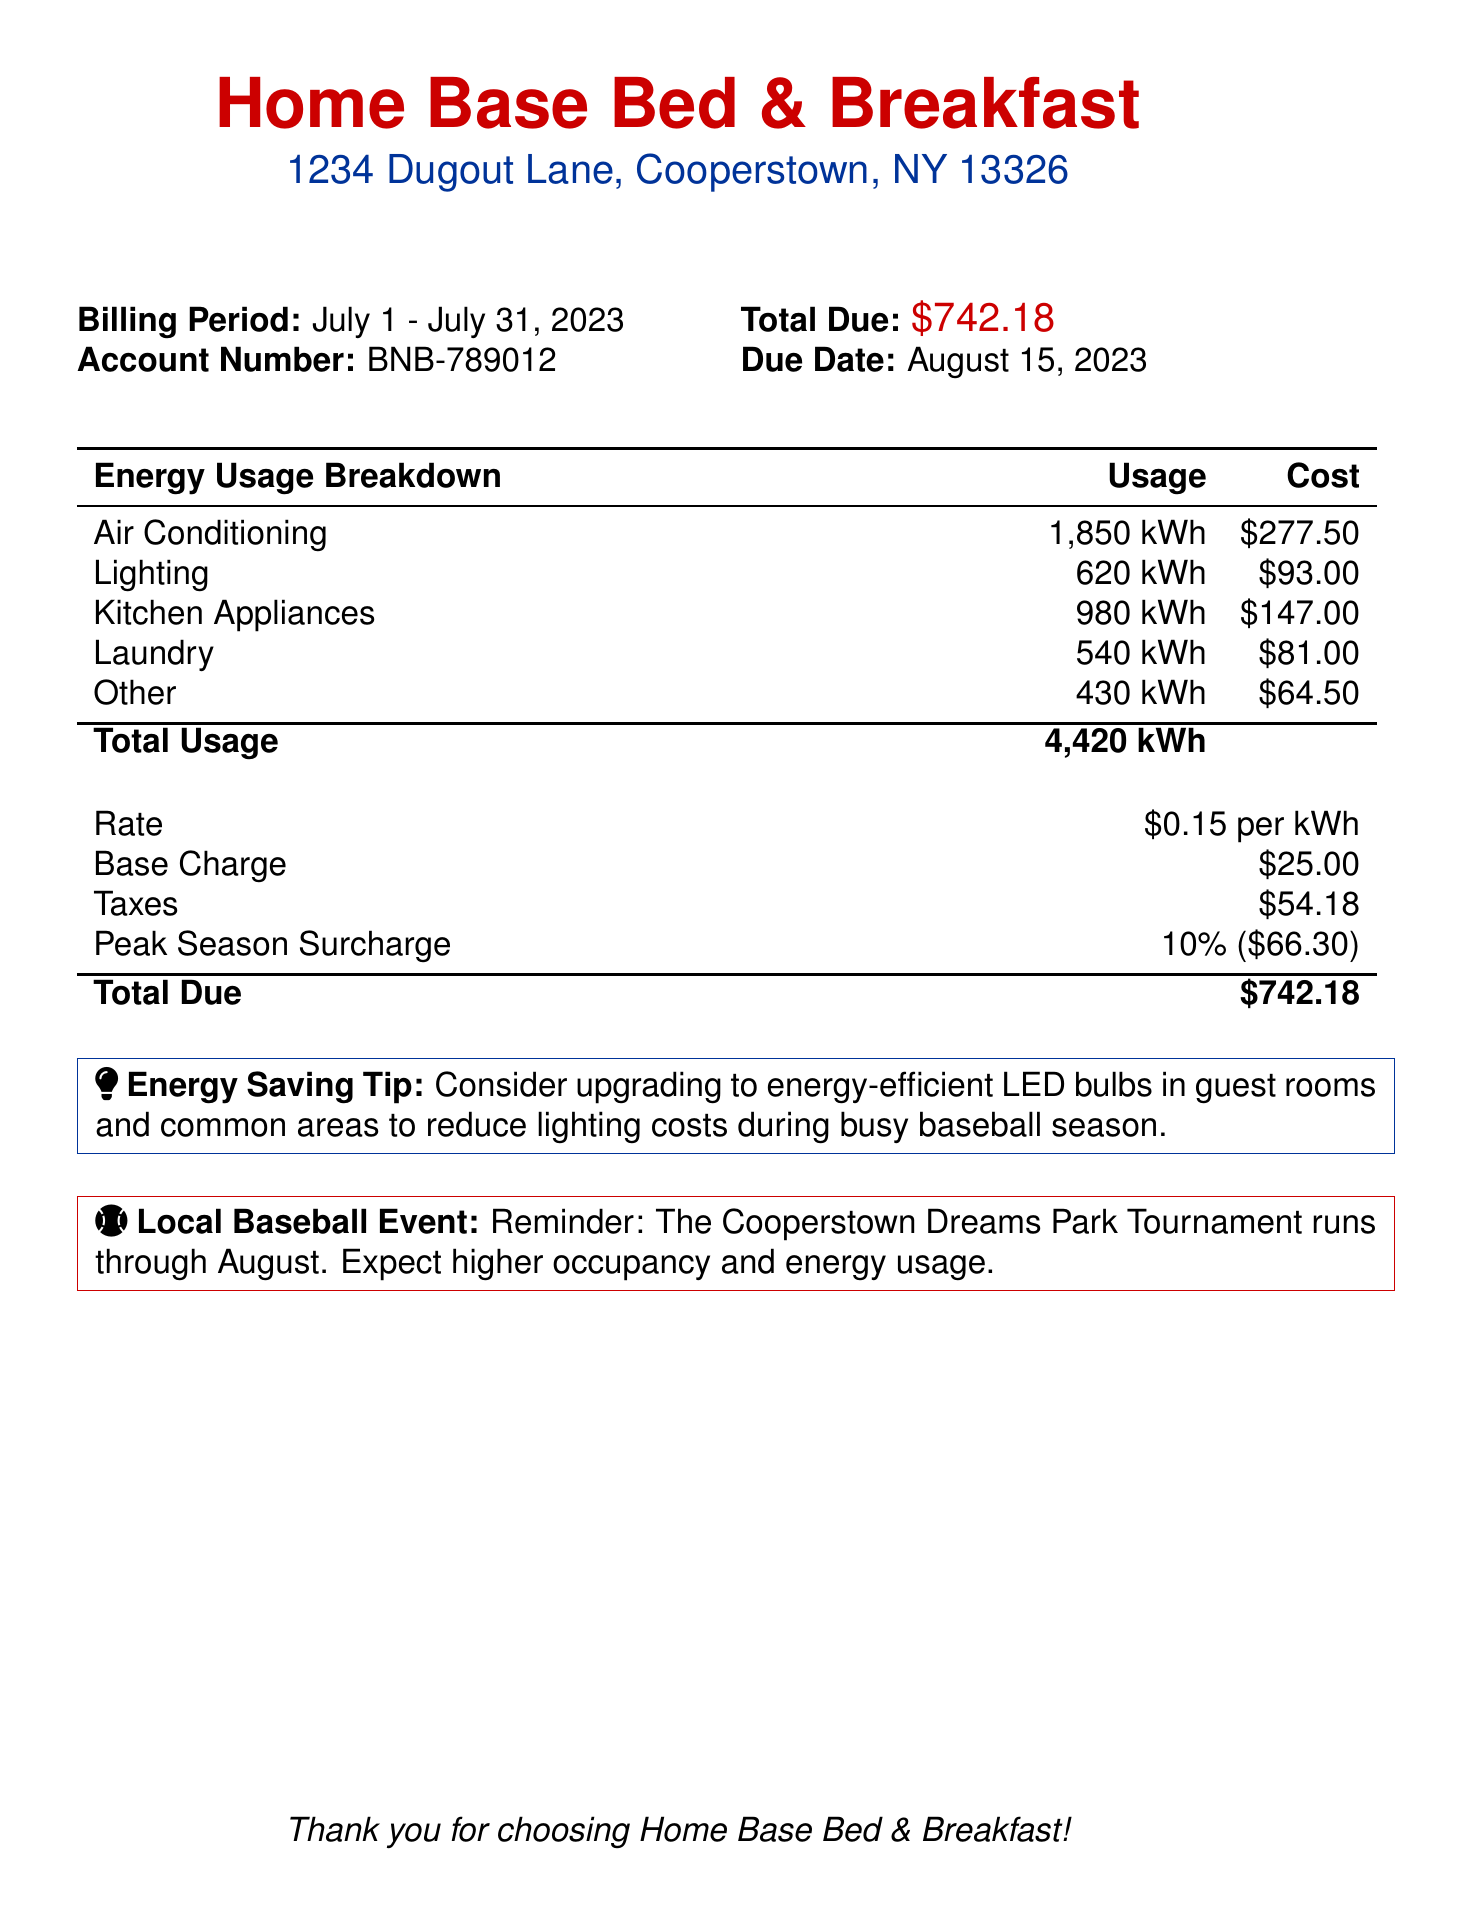What is the billing period? The billing period is specified in the document as July 1 to July 31, 2023.
Answer: July 1 - July 31, 2023 What is the total due amount? The total due amount is clearly stated in the document as $742.18.
Answer: $742.18 What is the account number? The account number is provided in the document as BNB-789012.
Answer: BNB-789012 How much energy was used for air conditioning? The energy usage for air conditioning is listed in the document as 1,850 kWh.
Answer: 1,850 kWh What is the peak season surcharge percentage? The document mentions the peak season surcharge as 10%.
Answer: 10% What is the base charge? The base charge is outlined as $25.00 in the document.
Answer: $25.00 What event is mentioned for the local baseball season? The document references the Cooperstown Dreams Park Tournament.
Answer: Cooperstown Dreams Park Tournament What energy saving tip is provided? The document advises upgrading to energy-efficient LED bulbs.
Answer: Upgrade to energy-efficient LED bulbs How much did lighting cost in this billing period? The cost for lighting is specified as $93.00 in the document.
Answer: $93.00 What is the total energy usage in kWh? The total energy usage is summarized as 4,420 kWh in the document.
Answer: 4,420 kWh 